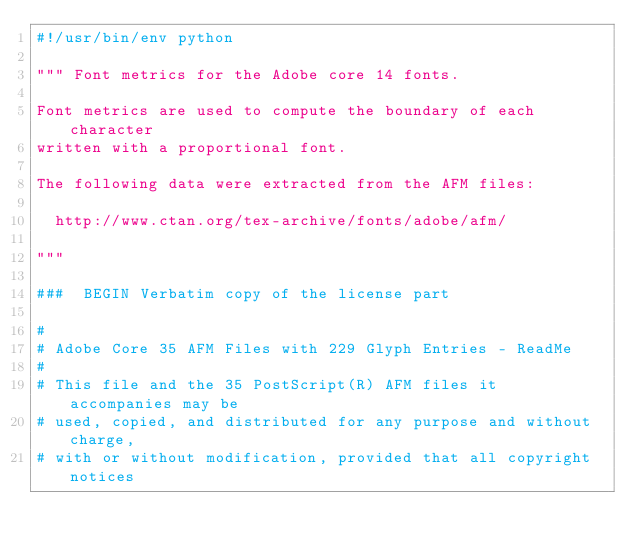<code> <loc_0><loc_0><loc_500><loc_500><_Python_>#!/usr/bin/env python

""" Font metrics for the Adobe core 14 fonts.

Font metrics are used to compute the boundary of each character
written with a proportional font.

The following data were extracted from the AFM files:

  http://www.ctan.org/tex-archive/fonts/adobe/afm/
  
"""

###  BEGIN Verbatim copy of the license part

#
# Adobe Core 35 AFM Files with 229 Glyph Entries - ReadMe
#
# This file and the 35 PostScript(R) AFM files it accompanies may be
# used, copied, and distributed for any purpose and without charge,
# with or without modification, provided that all copyright notices</code> 